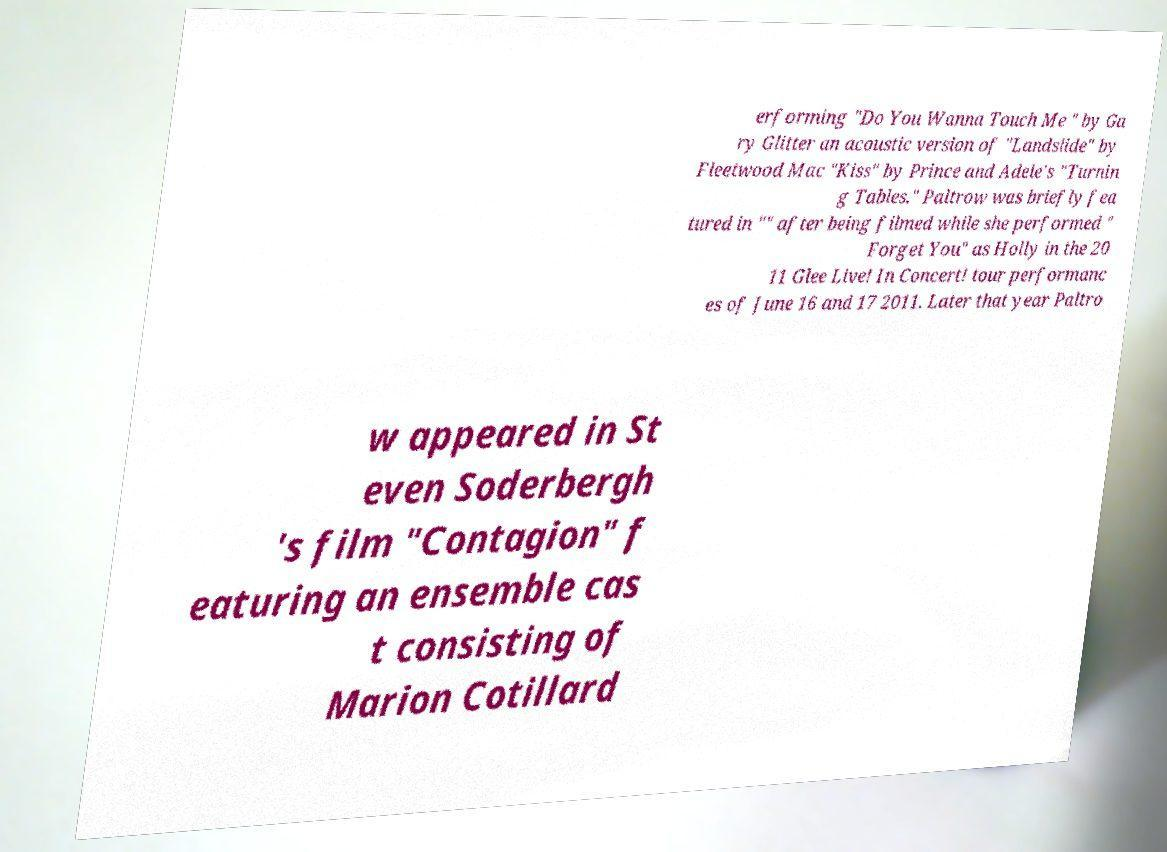What messages or text are displayed in this image? I need them in a readable, typed format. erforming "Do You Wanna Touch Me " by Ga ry Glitter an acoustic version of "Landslide" by Fleetwood Mac "Kiss" by Prince and Adele's "Turnin g Tables." Paltrow was briefly fea tured in "" after being filmed while she performed " Forget You" as Holly in the 20 11 Glee Live! In Concert! tour performanc es of June 16 and 17 2011. Later that year Paltro w appeared in St even Soderbergh 's film "Contagion" f eaturing an ensemble cas t consisting of Marion Cotillard 